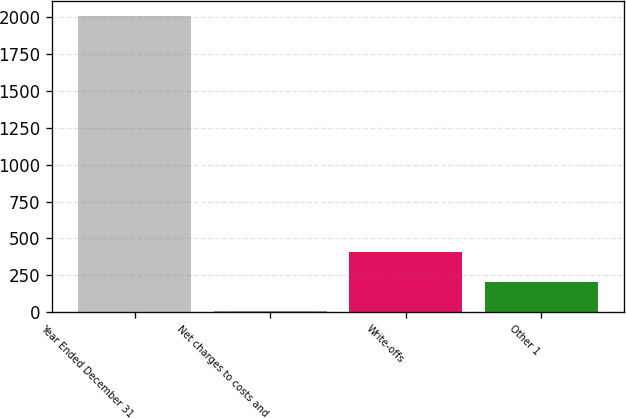Convert chart to OTSL. <chart><loc_0><loc_0><loc_500><loc_500><bar_chart><fcel>Year Ended December 31<fcel>Net charges to costs and<fcel>Write-offs<fcel>Other 1<nl><fcel>2012<fcel>5<fcel>406.4<fcel>205.7<nl></chart> 